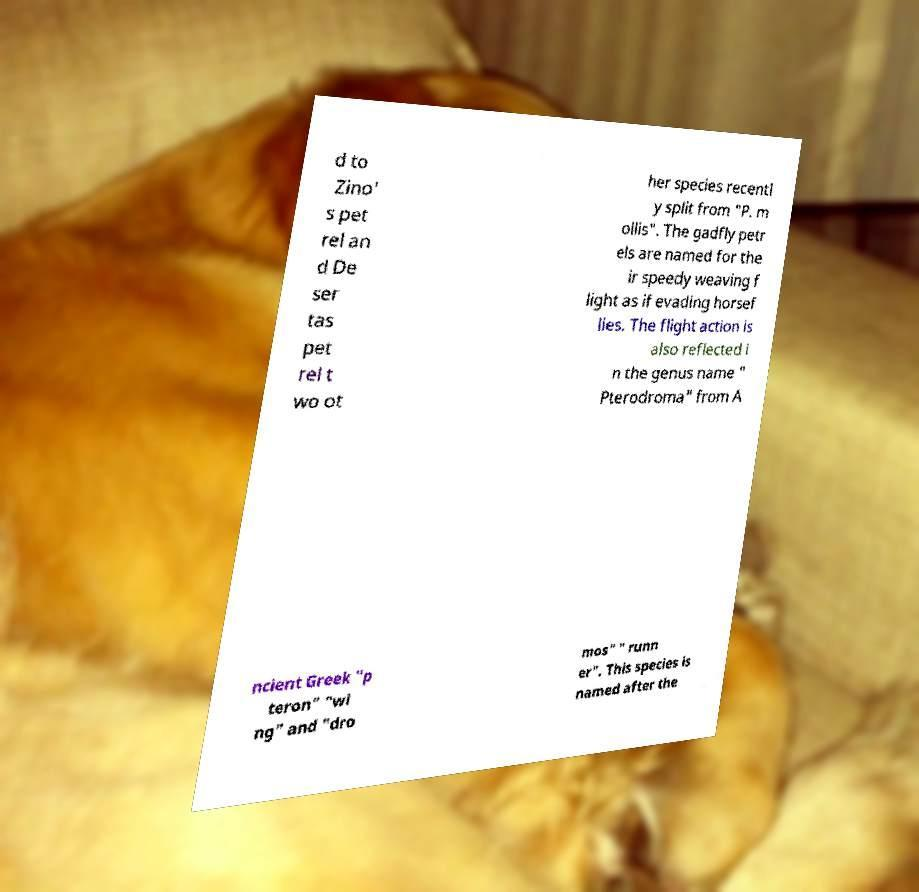Please read and relay the text visible in this image. What does it say? d to Zino' s pet rel an d De ser tas pet rel t wo ot her species recentl y split from "P. m ollis". The gadfly petr els are named for the ir speedy weaving f light as if evading horsef lies. The flight action is also reflected i n the genus name " Pterodroma" from A ncient Greek "p teron" "wi ng" and "dro mos" " runn er". This species is named after the 